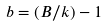Convert formula to latex. <formula><loc_0><loc_0><loc_500><loc_500>b = ( B / k ) - 1</formula> 